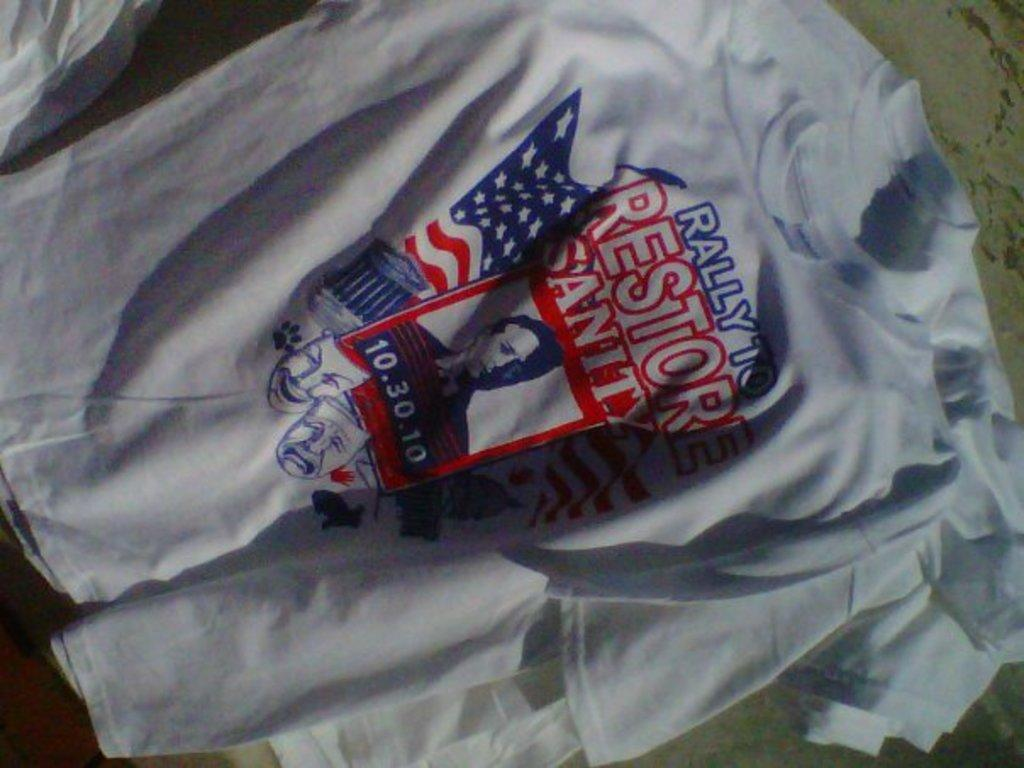<image>
Relay a brief, clear account of the picture shown. A shirt with the words Rally to restore sanity on it 